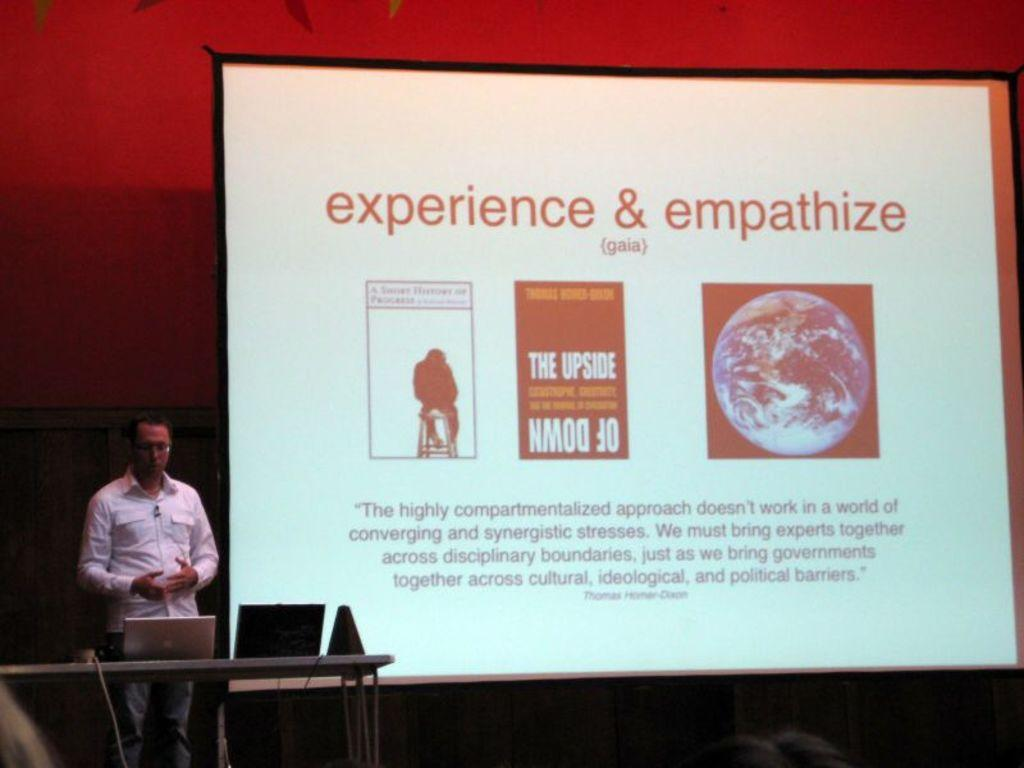<image>
Create a compact narrative representing the image presented. man lecturing and showing a presentation about experience & empathize 